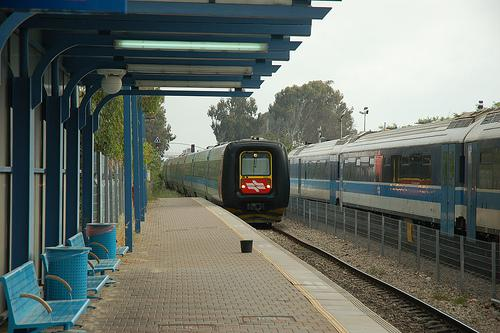In this image, which object separates the trains? A metal fence separates the trains. Mention any color and object prominently visible in the area surrounding train tracks. A blue garbage can, a blue bench, and a yellow caution line are around train tracks. What is the color of the train passenger car in the image? The train passenger car is white and blue. Which objects are mentioned in the image that gives a sense of caution or safety? A yellow caution line at the train station and a fence between the trains. What type of light can be seen in the train platform area? A globe light and a long tube light are illuminated in the train platform area. Describe what the trains are doing in the image. The trains are leaving the station and approaching a platform. List two objects found at the train station platform and their colors. A blue bench with brown handles and a blue metal garbage can are at the train station platform. What are the two objects found next to the blue bench? A blue trashcan and a blue pole are next to the blue bench. Identify any objects placed near the mentioned building. A garbage can and a bench are placed next to the building. 